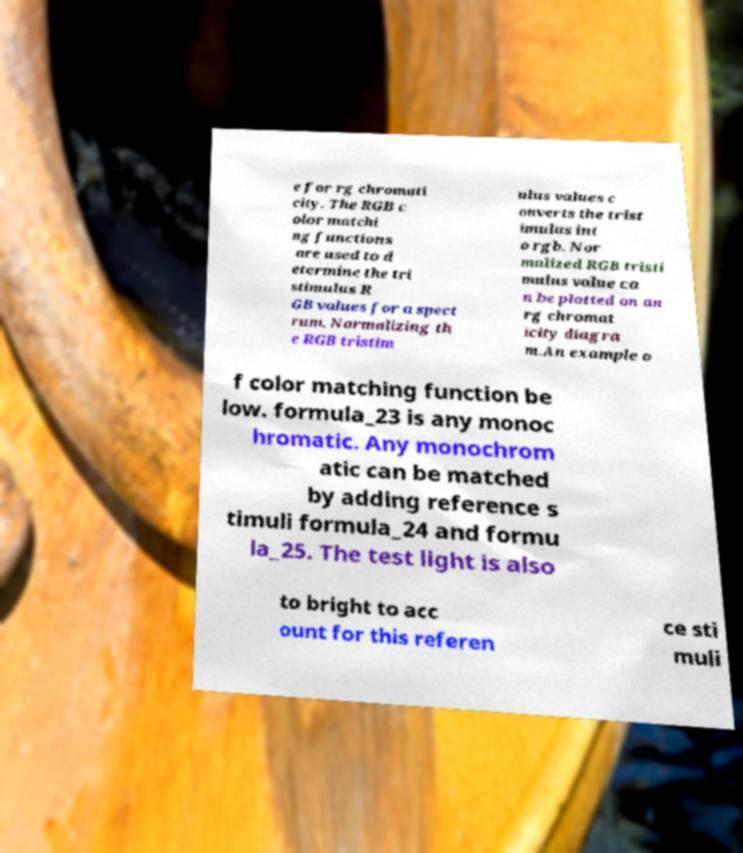There's text embedded in this image that I need extracted. Can you transcribe it verbatim? e for rg chromati city. The RGB c olor matchi ng functions are used to d etermine the tri stimulus R GB values for a spect rum. Normalizing th e RGB tristim ulus values c onverts the trist imulus int o rgb. Nor malized RGB tristi mulus value ca n be plotted on an rg chromat icity diagra m.An example o f color matching function be low. formula_23 is any monoc hromatic. Any monochrom atic can be matched by adding reference s timuli formula_24 and formu la_25. The test light is also to bright to acc ount for this referen ce sti muli 